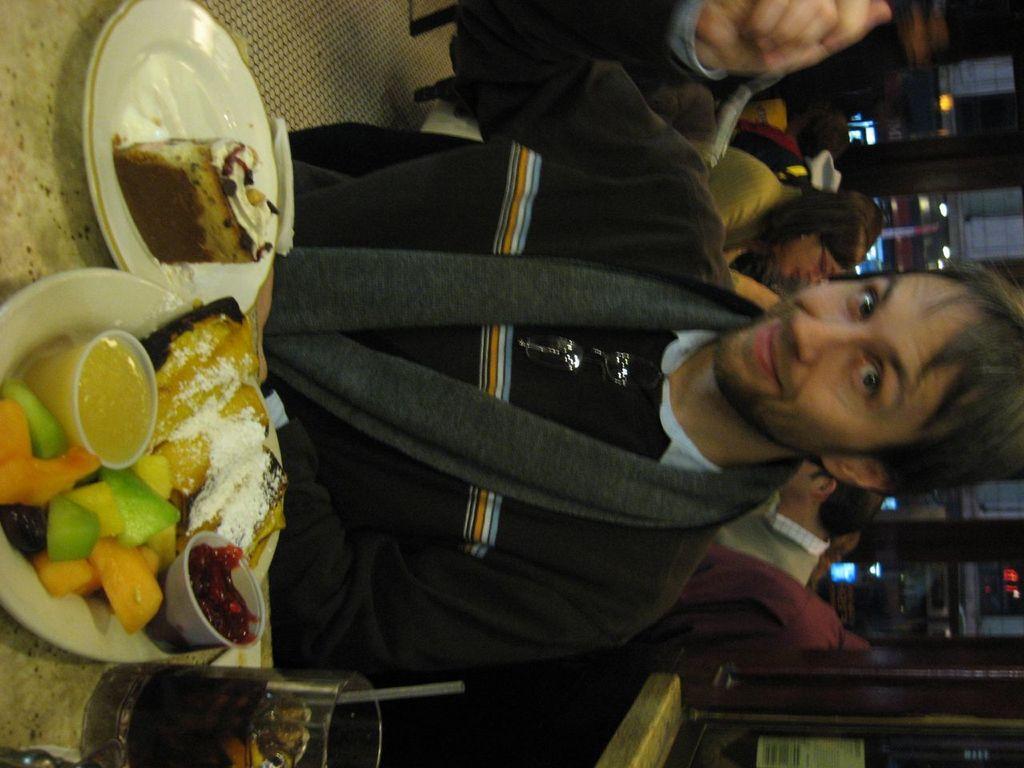In one or two sentences, can you explain what this image depicts? In this image we can see a person and an object. On the left side of the image there are some food items in the plates and a glass with some liquid on the surface. On the right side of the image there are some persons, glass objects and other objects. 